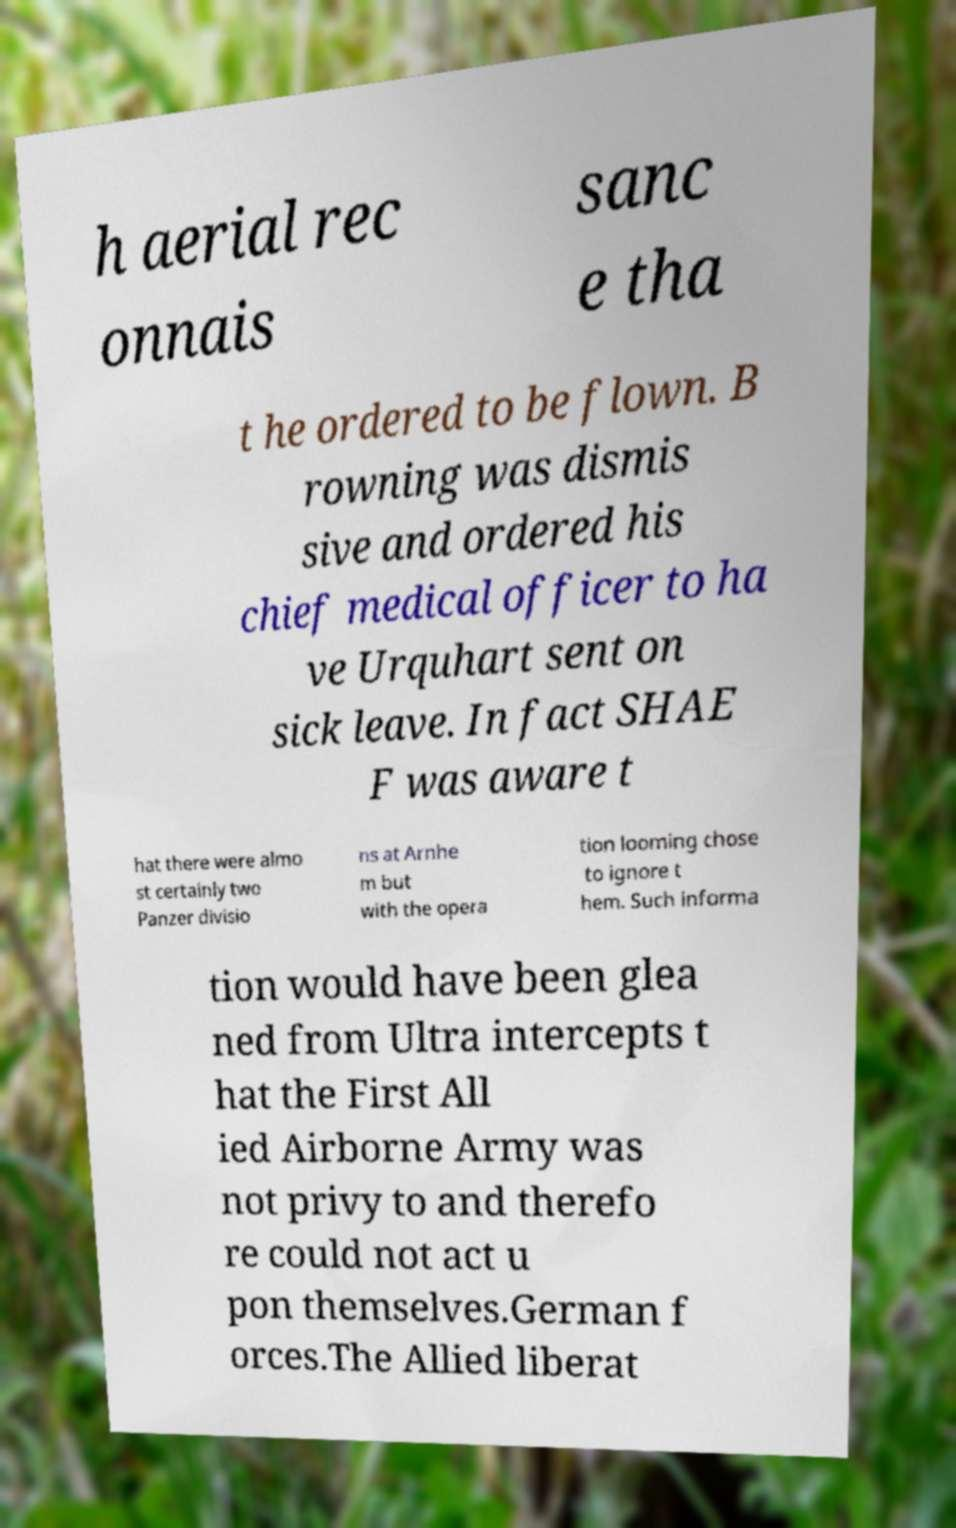There's text embedded in this image that I need extracted. Can you transcribe it verbatim? h aerial rec onnais sanc e tha t he ordered to be flown. B rowning was dismis sive and ordered his chief medical officer to ha ve Urquhart sent on sick leave. In fact SHAE F was aware t hat there were almo st certainly two Panzer divisio ns at Arnhe m but with the opera tion looming chose to ignore t hem. Such informa tion would have been glea ned from Ultra intercepts t hat the First All ied Airborne Army was not privy to and therefo re could not act u pon themselves.German f orces.The Allied liberat 